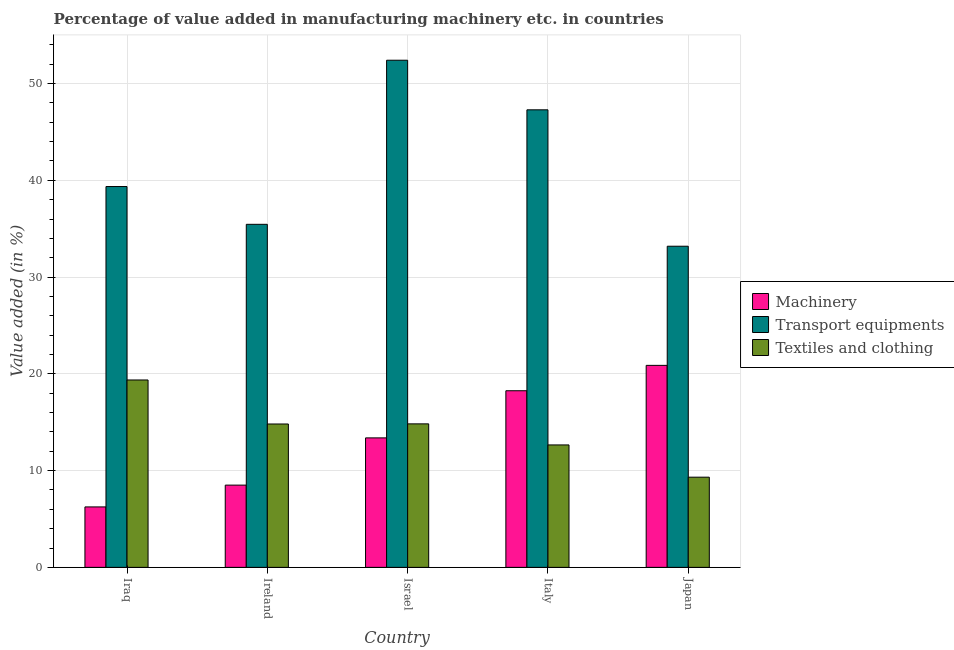How many groups of bars are there?
Your answer should be very brief. 5. Are the number of bars on each tick of the X-axis equal?
Offer a terse response. Yes. How many bars are there on the 4th tick from the left?
Provide a succinct answer. 3. What is the label of the 2nd group of bars from the left?
Offer a very short reply. Ireland. What is the value added in manufacturing transport equipments in Iraq?
Provide a short and direct response. 39.36. Across all countries, what is the maximum value added in manufacturing machinery?
Your response must be concise. 20.88. Across all countries, what is the minimum value added in manufacturing textile and clothing?
Give a very brief answer. 9.32. In which country was the value added in manufacturing machinery minimum?
Provide a short and direct response. Iraq. What is the total value added in manufacturing transport equipments in the graph?
Give a very brief answer. 207.7. What is the difference between the value added in manufacturing machinery in Italy and that in Japan?
Give a very brief answer. -2.62. What is the difference between the value added in manufacturing machinery in Italy and the value added in manufacturing transport equipments in Japan?
Your response must be concise. -14.94. What is the average value added in manufacturing textile and clothing per country?
Offer a very short reply. 14.2. What is the difference between the value added in manufacturing textile and clothing and value added in manufacturing machinery in Japan?
Your answer should be compact. -11.56. What is the ratio of the value added in manufacturing textile and clothing in Israel to that in Italy?
Give a very brief answer. 1.17. Is the difference between the value added in manufacturing transport equipments in Israel and Italy greater than the difference between the value added in manufacturing textile and clothing in Israel and Italy?
Ensure brevity in your answer.  Yes. What is the difference between the highest and the second highest value added in manufacturing machinery?
Offer a very short reply. 2.62. What is the difference between the highest and the lowest value added in manufacturing transport equipments?
Ensure brevity in your answer.  19.22. In how many countries, is the value added in manufacturing machinery greater than the average value added in manufacturing machinery taken over all countries?
Offer a very short reply. 2. Is the sum of the value added in manufacturing transport equipments in Israel and Japan greater than the maximum value added in manufacturing machinery across all countries?
Make the answer very short. Yes. What does the 2nd bar from the left in Ireland represents?
Ensure brevity in your answer.  Transport equipments. What does the 1st bar from the right in Italy represents?
Your response must be concise. Textiles and clothing. Is it the case that in every country, the sum of the value added in manufacturing machinery and value added in manufacturing transport equipments is greater than the value added in manufacturing textile and clothing?
Provide a succinct answer. Yes. What is the difference between two consecutive major ticks on the Y-axis?
Give a very brief answer. 10. Are the values on the major ticks of Y-axis written in scientific E-notation?
Offer a very short reply. No. Does the graph contain any zero values?
Keep it short and to the point. No. Where does the legend appear in the graph?
Make the answer very short. Center right. What is the title of the graph?
Provide a succinct answer. Percentage of value added in manufacturing machinery etc. in countries. Does "Transport services" appear as one of the legend labels in the graph?
Your response must be concise. No. What is the label or title of the X-axis?
Ensure brevity in your answer.  Country. What is the label or title of the Y-axis?
Offer a very short reply. Value added (in %). What is the Value added (in %) of Machinery in Iraq?
Offer a terse response. 6.25. What is the Value added (in %) of Transport equipments in Iraq?
Keep it short and to the point. 39.36. What is the Value added (in %) in Textiles and clothing in Iraq?
Your answer should be compact. 19.37. What is the Value added (in %) of Machinery in Ireland?
Provide a short and direct response. 8.5. What is the Value added (in %) in Transport equipments in Ireland?
Your response must be concise. 35.45. What is the Value added (in %) of Textiles and clothing in Ireland?
Give a very brief answer. 14.82. What is the Value added (in %) of Machinery in Israel?
Your response must be concise. 13.38. What is the Value added (in %) of Transport equipments in Israel?
Make the answer very short. 52.41. What is the Value added (in %) of Textiles and clothing in Israel?
Your answer should be compact. 14.83. What is the Value added (in %) in Machinery in Italy?
Your response must be concise. 18.25. What is the Value added (in %) of Transport equipments in Italy?
Your answer should be compact. 47.29. What is the Value added (in %) in Textiles and clothing in Italy?
Offer a very short reply. 12.65. What is the Value added (in %) in Machinery in Japan?
Your response must be concise. 20.88. What is the Value added (in %) in Transport equipments in Japan?
Ensure brevity in your answer.  33.19. What is the Value added (in %) of Textiles and clothing in Japan?
Your response must be concise. 9.32. Across all countries, what is the maximum Value added (in %) in Machinery?
Ensure brevity in your answer.  20.88. Across all countries, what is the maximum Value added (in %) in Transport equipments?
Make the answer very short. 52.41. Across all countries, what is the maximum Value added (in %) in Textiles and clothing?
Provide a succinct answer. 19.37. Across all countries, what is the minimum Value added (in %) of Machinery?
Give a very brief answer. 6.25. Across all countries, what is the minimum Value added (in %) in Transport equipments?
Make the answer very short. 33.19. Across all countries, what is the minimum Value added (in %) in Textiles and clothing?
Provide a succinct answer. 9.32. What is the total Value added (in %) of Machinery in the graph?
Give a very brief answer. 67.26. What is the total Value added (in %) in Transport equipments in the graph?
Keep it short and to the point. 207.7. What is the total Value added (in %) of Textiles and clothing in the graph?
Your answer should be very brief. 70.99. What is the difference between the Value added (in %) in Machinery in Iraq and that in Ireland?
Keep it short and to the point. -2.25. What is the difference between the Value added (in %) in Transport equipments in Iraq and that in Ireland?
Provide a succinct answer. 3.91. What is the difference between the Value added (in %) in Textiles and clothing in Iraq and that in Ireland?
Keep it short and to the point. 4.55. What is the difference between the Value added (in %) in Machinery in Iraq and that in Israel?
Provide a succinct answer. -7.13. What is the difference between the Value added (in %) of Transport equipments in Iraq and that in Israel?
Your answer should be very brief. -13.05. What is the difference between the Value added (in %) of Textiles and clothing in Iraq and that in Israel?
Provide a short and direct response. 4.54. What is the difference between the Value added (in %) of Machinery in Iraq and that in Italy?
Your answer should be compact. -12.01. What is the difference between the Value added (in %) of Transport equipments in Iraq and that in Italy?
Offer a very short reply. -7.93. What is the difference between the Value added (in %) of Textiles and clothing in Iraq and that in Italy?
Provide a succinct answer. 6.71. What is the difference between the Value added (in %) of Machinery in Iraq and that in Japan?
Provide a short and direct response. -14.63. What is the difference between the Value added (in %) of Transport equipments in Iraq and that in Japan?
Ensure brevity in your answer.  6.17. What is the difference between the Value added (in %) of Textiles and clothing in Iraq and that in Japan?
Offer a very short reply. 10.05. What is the difference between the Value added (in %) in Machinery in Ireland and that in Israel?
Your answer should be very brief. -4.88. What is the difference between the Value added (in %) of Transport equipments in Ireland and that in Israel?
Give a very brief answer. -16.96. What is the difference between the Value added (in %) of Textiles and clothing in Ireland and that in Israel?
Make the answer very short. -0.01. What is the difference between the Value added (in %) in Machinery in Ireland and that in Italy?
Your response must be concise. -9.75. What is the difference between the Value added (in %) of Transport equipments in Ireland and that in Italy?
Provide a short and direct response. -11.83. What is the difference between the Value added (in %) in Textiles and clothing in Ireland and that in Italy?
Your response must be concise. 2.16. What is the difference between the Value added (in %) in Machinery in Ireland and that in Japan?
Give a very brief answer. -12.38. What is the difference between the Value added (in %) in Transport equipments in Ireland and that in Japan?
Give a very brief answer. 2.26. What is the difference between the Value added (in %) in Textiles and clothing in Ireland and that in Japan?
Give a very brief answer. 5.5. What is the difference between the Value added (in %) in Machinery in Israel and that in Italy?
Offer a very short reply. -4.87. What is the difference between the Value added (in %) of Transport equipments in Israel and that in Italy?
Offer a terse response. 5.13. What is the difference between the Value added (in %) of Textiles and clothing in Israel and that in Italy?
Ensure brevity in your answer.  2.18. What is the difference between the Value added (in %) in Machinery in Israel and that in Japan?
Your response must be concise. -7.5. What is the difference between the Value added (in %) in Transport equipments in Israel and that in Japan?
Your answer should be very brief. 19.22. What is the difference between the Value added (in %) of Textiles and clothing in Israel and that in Japan?
Offer a terse response. 5.51. What is the difference between the Value added (in %) of Machinery in Italy and that in Japan?
Provide a succinct answer. -2.62. What is the difference between the Value added (in %) of Transport equipments in Italy and that in Japan?
Offer a terse response. 14.1. What is the difference between the Value added (in %) of Textiles and clothing in Italy and that in Japan?
Offer a very short reply. 3.33. What is the difference between the Value added (in %) of Machinery in Iraq and the Value added (in %) of Transport equipments in Ireland?
Make the answer very short. -29.21. What is the difference between the Value added (in %) of Machinery in Iraq and the Value added (in %) of Textiles and clothing in Ireland?
Ensure brevity in your answer.  -8.57. What is the difference between the Value added (in %) in Transport equipments in Iraq and the Value added (in %) in Textiles and clothing in Ireland?
Make the answer very short. 24.54. What is the difference between the Value added (in %) of Machinery in Iraq and the Value added (in %) of Transport equipments in Israel?
Offer a very short reply. -46.17. What is the difference between the Value added (in %) of Machinery in Iraq and the Value added (in %) of Textiles and clothing in Israel?
Provide a short and direct response. -8.58. What is the difference between the Value added (in %) of Transport equipments in Iraq and the Value added (in %) of Textiles and clothing in Israel?
Ensure brevity in your answer.  24.53. What is the difference between the Value added (in %) of Machinery in Iraq and the Value added (in %) of Transport equipments in Italy?
Your response must be concise. -41.04. What is the difference between the Value added (in %) in Machinery in Iraq and the Value added (in %) in Textiles and clothing in Italy?
Offer a terse response. -6.41. What is the difference between the Value added (in %) in Transport equipments in Iraq and the Value added (in %) in Textiles and clothing in Italy?
Provide a succinct answer. 26.71. What is the difference between the Value added (in %) of Machinery in Iraq and the Value added (in %) of Transport equipments in Japan?
Keep it short and to the point. -26.94. What is the difference between the Value added (in %) in Machinery in Iraq and the Value added (in %) in Textiles and clothing in Japan?
Keep it short and to the point. -3.07. What is the difference between the Value added (in %) of Transport equipments in Iraq and the Value added (in %) of Textiles and clothing in Japan?
Your answer should be very brief. 30.04. What is the difference between the Value added (in %) of Machinery in Ireland and the Value added (in %) of Transport equipments in Israel?
Ensure brevity in your answer.  -43.91. What is the difference between the Value added (in %) of Machinery in Ireland and the Value added (in %) of Textiles and clothing in Israel?
Give a very brief answer. -6.33. What is the difference between the Value added (in %) of Transport equipments in Ireland and the Value added (in %) of Textiles and clothing in Israel?
Your response must be concise. 20.62. What is the difference between the Value added (in %) of Machinery in Ireland and the Value added (in %) of Transport equipments in Italy?
Make the answer very short. -38.79. What is the difference between the Value added (in %) in Machinery in Ireland and the Value added (in %) in Textiles and clothing in Italy?
Provide a succinct answer. -4.15. What is the difference between the Value added (in %) in Transport equipments in Ireland and the Value added (in %) in Textiles and clothing in Italy?
Your response must be concise. 22.8. What is the difference between the Value added (in %) of Machinery in Ireland and the Value added (in %) of Transport equipments in Japan?
Your response must be concise. -24.69. What is the difference between the Value added (in %) of Machinery in Ireland and the Value added (in %) of Textiles and clothing in Japan?
Offer a terse response. -0.82. What is the difference between the Value added (in %) in Transport equipments in Ireland and the Value added (in %) in Textiles and clothing in Japan?
Offer a terse response. 26.13. What is the difference between the Value added (in %) in Machinery in Israel and the Value added (in %) in Transport equipments in Italy?
Your response must be concise. -33.91. What is the difference between the Value added (in %) of Machinery in Israel and the Value added (in %) of Textiles and clothing in Italy?
Provide a short and direct response. 0.73. What is the difference between the Value added (in %) of Transport equipments in Israel and the Value added (in %) of Textiles and clothing in Italy?
Your answer should be compact. 39.76. What is the difference between the Value added (in %) of Machinery in Israel and the Value added (in %) of Transport equipments in Japan?
Give a very brief answer. -19.81. What is the difference between the Value added (in %) in Machinery in Israel and the Value added (in %) in Textiles and clothing in Japan?
Offer a terse response. 4.06. What is the difference between the Value added (in %) in Transport equipments in Israel and the Value added (in %) in Textiles and clothing in Japan?
Give a very brief answer. 43.09. What is the difference between the Value added (in %) of Machinery in Italy and the Value added (in %) of Transport equipments in Japan?
Your response must be concise. -14.94. What is the difference between the Value added (in %) in Machinery in Italy and the Value added (in %) in Textiles and clothing in Japan?
Offer a very short reply. 8.93. What is the difference between the Value added (in %) of Transport equipments in Italy and the Value added (in %) of Textiles and clothing in Japan?
Offer a terse response. 37.97. What is the average Value added (in %) of Machinery per country?
Provide a short and direct response. 13.45. What is the average Value added (in %) of Transport equipments per country?
Offer a very short reply. 41.54. What is the average Value added (in %) in Textiles and clothing per country?
Provide a short and direct response. 14.2. What is the difference between the Value added (in %) of Machinery and Value added (in %) of Transport equipments in Iraq?
Offer a very short reply. -33.11. What is the difference between the Value added (in %) in Machinery and Value added (in %) in Textiles and clothing in Iraq?
Provide a short and direct response. -13.12. What is the difference between the Value added (in %) in Transport equipments and Value added (in %) in Textiles and clothing in Iraq?
Provide a short and direct response. 19.99. What is the difference between the Value added (in %) in Machinery and Value added (in %) in Transport equipments in Ireland?
Offer a terse response. -26.95. What is the difference between the Value added (in %) in Machinery and Value added (in %) in Textiles and clothing in Ireland?
Make the answer very short. -6.32. What is the difference between the Value added (in %) of Transport equipments and Value added (in %) of Textiles and clothing in Ireland?
Ensure brevity in your answer.  20.64. What is the difference between the Value added (in %) in Machinery and Value added (in %) in Transport equipments in Israel?
Your response must be concise. -39.03. What is the difference between the Value added (in %) in Machinery and Value added (in %) in Textiles and clothing in Israel?
Your answer should be compact. -1.45. What is the difference between the Value added (in %) of Transport equipments and Value added (in %) of Textiles and clothing in Israel?
Your response must be concise. 37.58. What is the difference between the Value added (in %) of Machinery and Value added (in %) of Transport equipments in Italy?
Your answer should be compact. -29.03. What is the difference between the Value added (in %) in Machinery and Value added (in %) in Textiles and clothing in Italy?
Provide a succinct answer. 5.6. What is the difference between the Value added (in %) in Transport equipments and Value added (in %) in Textiles and clothing in Italy?
Ensure brevity in your answer.  34.63. What is the difference between the Value added (in %) of Machinery and Value added (in %) of Transport equipments in Japan?
Give a very brief answer. -12.31. What is the difference between the Value added (in %) of Machinery and Value added (in %) of Textiles and clothing in Japan?
Offer a terse response. 11.56. What is the difference between the Value added (in %) in Transport equipments and Value added (in %) in Textiles and clothing in Japan?
Offer a terse response. 23.87. What is the ratio of the Value added (in %) of Machinery in Iraq to that in Ireland?
Your response must be concise. 0.73. What is the ratio of the Value added (in %) of Transport equipments in Iraq to that in Ireland?
Give a very brief answer. 1.11. What is the ratio of the Value added (in %) of Textiles and clothing in Iraq to that in Ireland?
Offer a very short reply. 1.31. What is the ratio of the Value added (in %) in Machinery in Iraq to that in Israel?
Offer a terse response. 0.47. What is the ratio of the Value added (in %) in Transport equipments in Iraq to that in Israel?
Give a very brief answer. 0.75. What is the ratio of the Value added (in %) of Textiles and clothing in Iraq to that in Israel?
Your response must be concise. 1.31. What is the ratio of the Value added (in %) in Machinery in Iraq to that in Italy?
Make the answer very short. 0.34. What is the ratio of the Value added (in %) in Transport equipments in Iraq to that in Italy?
Your answer should be very brief. 0.83. What is the ratio of the Value added (in %) in Textiles and clothing in Iraq to that in Italy?
Offer a very short reply. 1.53. What is the ratio of the Value added (in %) in Machinery in Iraq to that in Japan?
Keep it short and to the point. 0.3. What is the ratio of the Value added (in %) in Transport equipments in Iraq to that in Japan?
Your answer should be very brief. 1.19. What is the ratio of the Value added (in %) in Textiles and clothing in Iraq to that in Japan?
Offer a very short reply. 2.08. What is the ratio of the Value added (in %) of Machinery in Ireland to that in Israel?
Offer a terse response. 0.64. What is the ratio of the Value added (in %) of Transport equipments in Ireland to that in Israel?
Provide a short and direct response. 0.68. What is the ratio of the Value added (in %) of Machinery in Ireland to that in Italy?
Offer a very short reply. 0.47. What is the ratio of the Value added (in %) in Transport equipments in Ireland to that in Italy?
Provide a succinct answer. 0.75. What is the ratio of the Value added (in %) of Textiles and clothing in Ireland to that in Italy?
Offer a very short reply. 1.17. What is the ratio of the Value added (in %) in Machinery in Ireland to that in Japan?
Offer a terse response. 0.41. What is the ratio of the Value added (in %) in Transport equipments in Ireland to that in Japan?
Your response must be concise. 1.07. What is the ratio of the Value added (in %) of Textiles and clothing in Ireland to that in Japan?
Provide a succinct answer. 1.59. What is the ratio of the Value added (in %) in Machinery in Israel to that in Italy?
Your response must be concise. 0.73. What is the ratio of the Value added (in %) in Transport equipments in Israel to that in Italy?
Offer a very short reply. 1.11. What is the ratio of the Value added (in %) in Textiles and clothing in Israel to that in Italy?
Offer a terse response. 1.17. What is the ratio of the Value added (in %) in Machinery in Israel to that in Japan?
Give a very brief answer. 0.64. What is the ratio of the Value added (in %) in Transport equipments in Israel to that in Japan?
Your answer should be compact. 1.58. What is the ratio of the Value added (in %) in Textiles and clothing in Israel to that in Japan?
Provide a succinct answer. 1.59. What is the ratio of the Value added (in %) in Machinery in Italy to that in Japan?
Offer a very short reply. 0.87. What is the ratio of the Value added (in %) in Transport equipments in Italy to that in Japan?
Your answer should be compact. 1.42. What is the ratio of the Value added (in %) in Textiles and clothing in Italy to that in Japan?
Offer a very short reply. 1.36. What is the difference between the highest and the second highest Value added (in %) of Machinery?
Your answer should be compact. 2.62. What is the difference between the highest and the second highest Value added (in %) of Transport equipments?
Your answer should be compact. 5.13. What is the difference between the highest and the second highest Value added (in %) in Textiles and clothing?
Your answer should be compact. 4.54. What is the difference between the highest and the lowest Value added (in %) of Machinery?
Offer a very short reply. 14.63. What is the difference between the highest and the lowest Value added (in %) in Transport equipments?
Ensure brevity in your answer.  19.22. What is the difference between the highest and the lowest Value added (in %) of Textiles and clothing?
Keep it short and to the point. 10.05. 